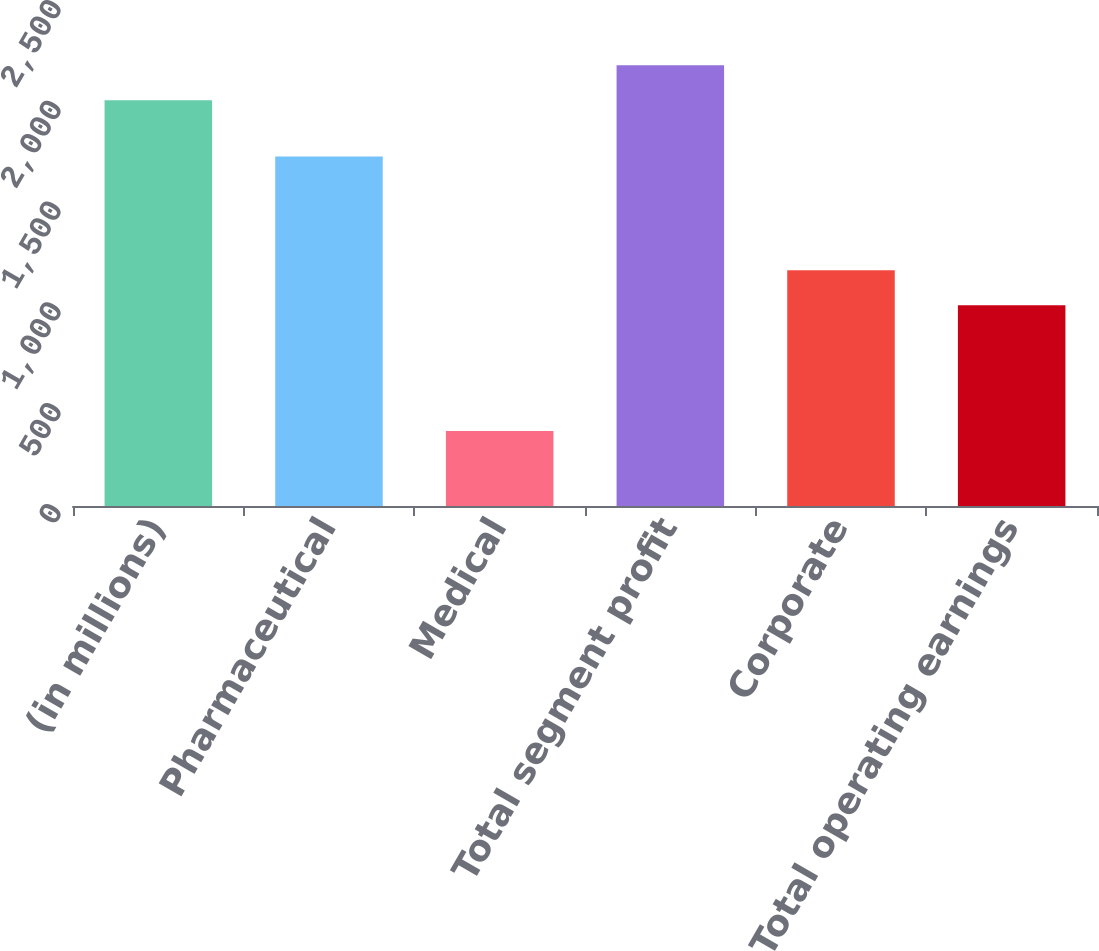<chart> <loc_0><loc_0><loc_500><loc_500><bar_chart><fcel>(in millions)<fcel>Pharmaceutical<fcel>Medical<fcel>Total segment profit<fcel>Corporate<fcel>Total operating earnings<nl><fcel>2013<fcel>1734<fcel>372<fcel>2186.4<fcel>1169.4<fcel>996<nl></chart> 